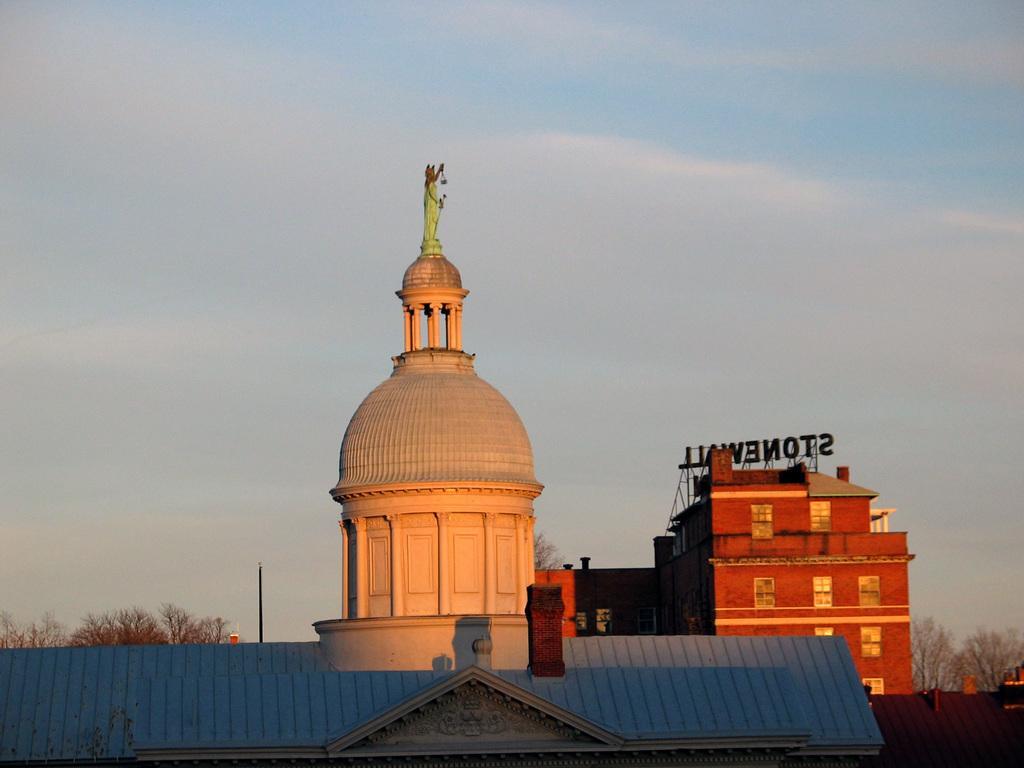In one or two sentences, can you explain what this image depicts? In this image there is a statue on the top of one of the buildings, there are trees, a pole and some clouds in the sky. 